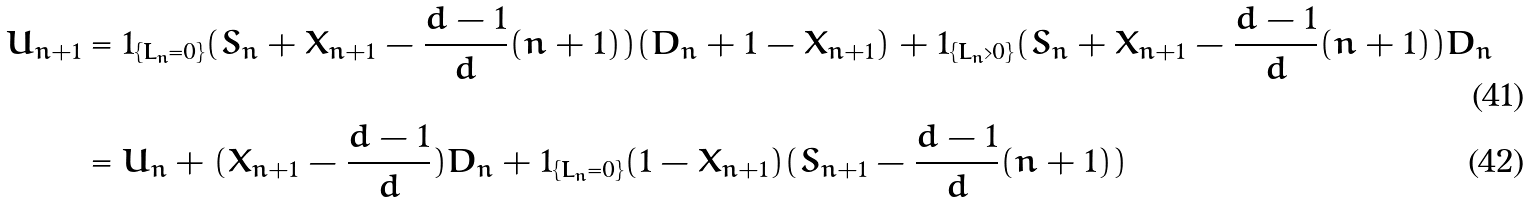<formula> <loc_0><loc_0><loc_500><loc_500>U _ { n + 1 } & = 1 _ { \{ L _ { n } = 0 \} } ( S _ { n } + X _ { n + 1 } - \frac { d - 1 } { d } ( n + 1 ) ) ( D _ { n } + 1 - X _ { n + 1 } ) + 1 _ { \{ L _ { n } > 0 \} } ( S _ { n } + X _ { n + 1 } - \frac { d - 1 } { d } ( n + 1 ) ) D _ { n } \\ & = U _ { n } + ( X _ { n + 1 } - \frac { d - 1 } { d } ) D _ { n } + 1 _ { \{ L _ { n } = 0 \} } ( 1 - X _ { n + 1 } ) ( S _ { n + 1 } - \frac { d - 1 } { d } ( n + 1 ) )</formula> 